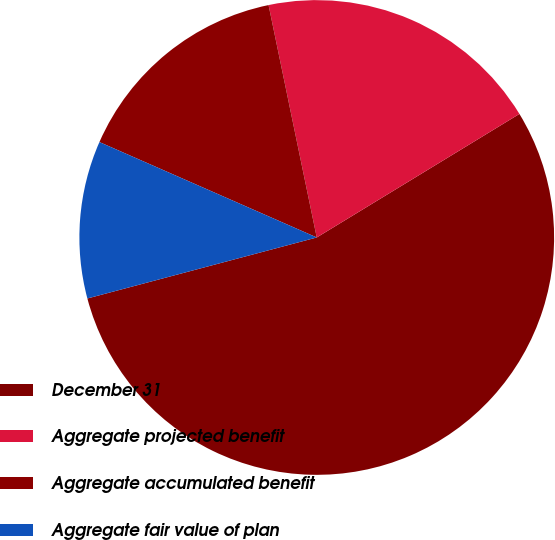<chart> <loc_0><loc_0><loc_500><loc_500><pie_chart><fcel>December 31<fcel>Aggregate projected benefit<fcel>Aggregate accumulated benefit<fcel>Aggregate fair value of plan<nl><fcel>54.57%<fcel>19.54%<fcel>15.16%<fcel>10.72%<nl></chart> 